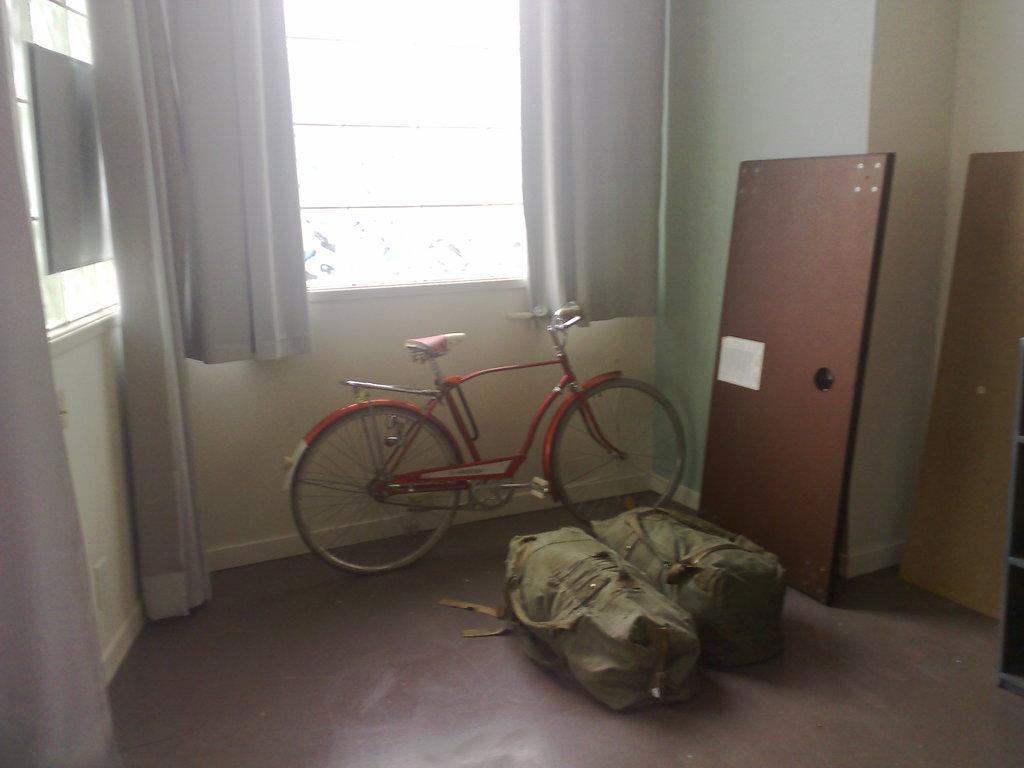Describe this image in one or two sentences. In the middle it is a cycle which is in red color and there are 2 luggage bags. This is a window. 